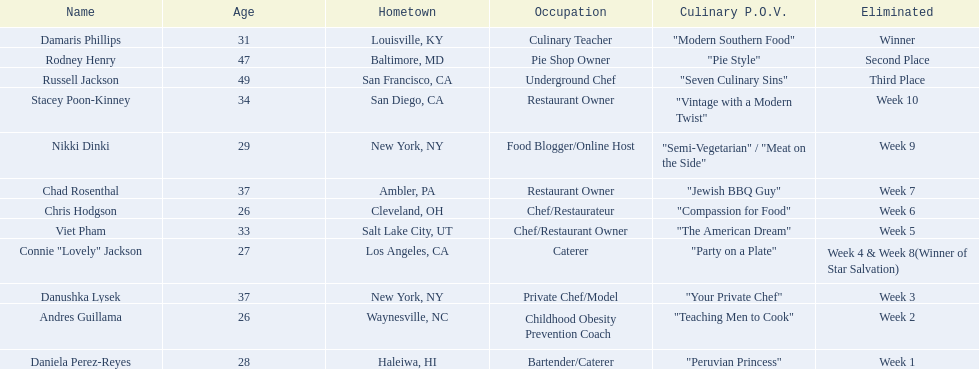Which contestant's culinary point of view had a longer description than "vintage with a modern twist"? Nikki Dinki. 